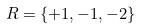<formula> <loc_0><loc_0><loc_500><loc_500>R = \{ + 1 , - 1 , - 2 \}</formula> 